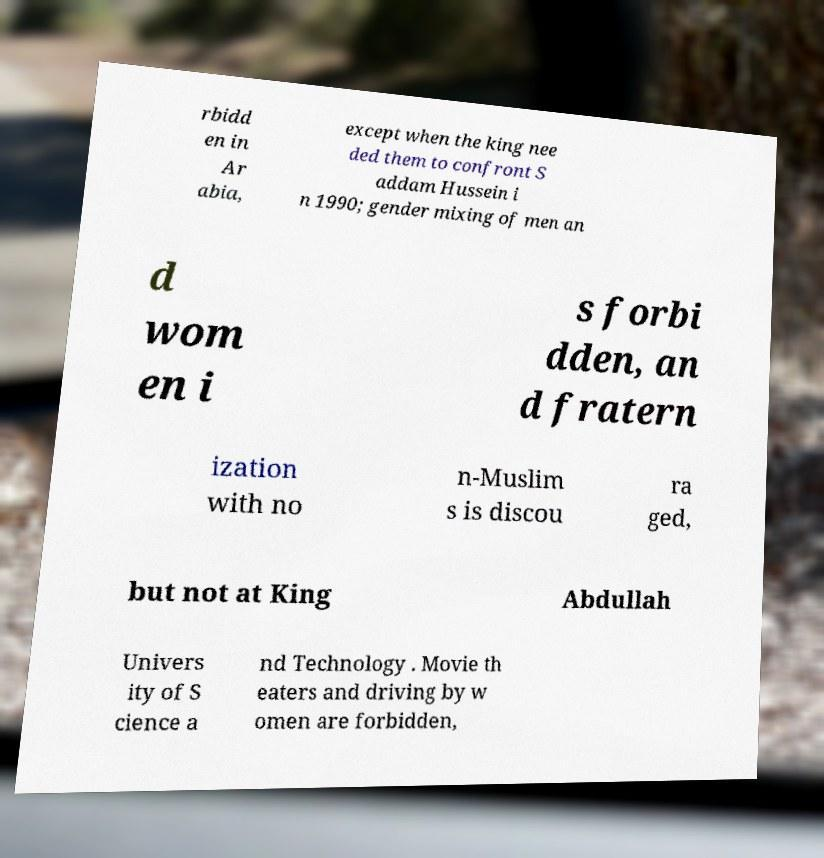For documentation purposes, I need the text within this image transcribed. Could you provide that? rbidd en in Ar abia, except when the king nee ded them to confront S addam Hussein i n 1990; gender mixing of men an d wom en i s forbi dden, an d fratern ization with no n-Muslim s is discou ra ged, but not at King Abdullah Univers ity of S cience a nd Technology . Movie th eaters and driving by w omen are forbidden, 